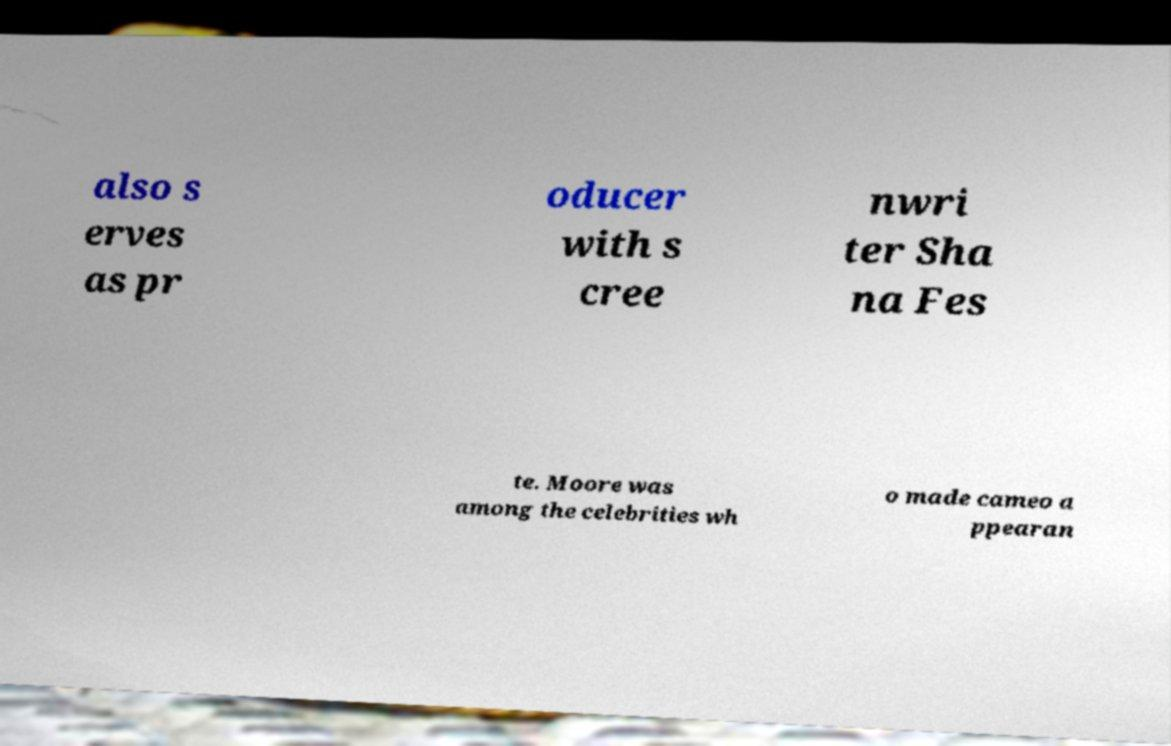Could you assist in decoding the text presented in this image and type it out clearly? also s erves as pr oducer with s cree nwri ter Sha na Fes te. Moore was among the celebrities wh o made cameo a ppearan 